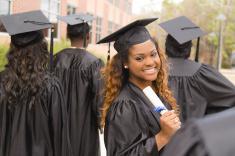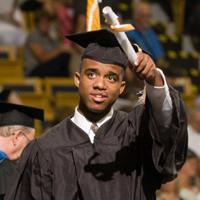The first image is the image on the left, the second image is the image on the right. Considering the images on both sides, is "A male is holding his diploma in the image on the right." valid? Answer yes or no. Yes. The first image is the image on the left, the second image is the image on the right. Analyze the images presented: Is the assertion "The diplomas the people are holding have red ribbons around them." valid? Answer yes or no. No. 